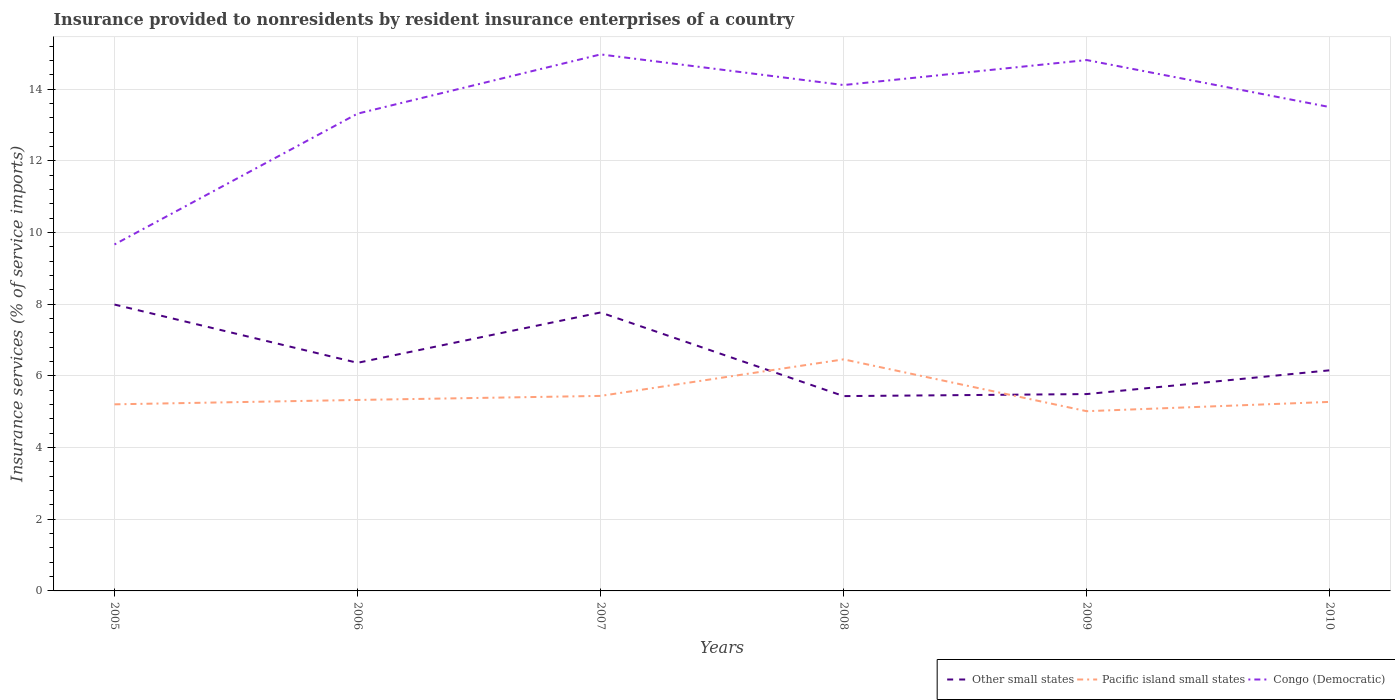How many different coloured lines are there?
Offer a terse response. 3. Does the line corresponding to Pacific island small states intersect with the line corresponding to Other small states?
Your answer should be very brief. Yes. Across all years, what is the maximum insurance provided to nonresidents in Other small states?
Your response must be concise. 5.43. What is the total insurance provided to nonresidents in Other small states in the graph?
Your answer should be compact. 1.63. What is the difference between the highest and the second highest insurance provided to nonresidents in Other small states?
Your answer should be compact. 2.55. What is the difference between the highest and the lowest insurance provided to nonresidents in Other small states?
Ensure brevity in your answer.  2. How many lines are there?
Offer a very short reply. 3. How many years are there in the graph?
Your answer should be very brief. 6. Are the values on the major ticks of Y-axis written in scientific E-notation?
Offer a very short reply. No. Does the graph contain grids?
Offer a very short reply. Yes. Where does the legend appear in the graph?
Keep it short and to the point. Bottom right. How are the legend labels stacked?
Provide a short and direct response. Horizontal. What is the title of the graph?
Keep it short and to the point. Insurance provided to nonresidents by resident insurance enterprises of a country. Does "Upper middle income" appear as one of the legend labels in the graph?
Keep it short and to the point. No. What is the label or title of the X-axis?
Make the answer very short. Years. What is the label or title of the Y-axis?
Provide a short and direct response. Insurance services (% of service imports). What is the Insurance services (% of service imports) of Other small states in 2005?
Provide a succinct answer. 7.99. What is the Insurance services (% of service imports) of Pacific island small states in 2005?
Provide a short and direct response. 5.21. What is the Insurance services (% of service imports) of Congo (Democratic) in 2005?
Provide a short and direct response. 9.66. What is the Insurance services (% of service imports) in Other small states in 2006?
Ensure brevity in your answer.  6.36. What is the Insurance services (% of service imports) in Pacific island small states in 2006?
Your answer should be compact. 5.33. What is the Insurance services (% of service imports) of Congo (Democratic) in 2006?
Give a very brief answer. 13.31. What is the Insurance services (% of service imports) in Other small states in 2007?
Provide a succinct answer. 7.77. What is the Insurance services (% of service imports) in Pacific island small states in 2007?
Keep it short and to the point. 5.44. What is the Insurance services (% of service imports) of Congo (Democratic) in 2007?
Give a very brief answer. 14.97. What is the Insurance services (% of service imports) of Other small states in 2008?
Your answer should be compact. 5.43. What is the Insurance services (% of service imports) in Pacific island small states in 2008?
Your answer should be compact. 6.46. What is the Insurance services (% of service imports) of Congo (Democratic) in 2008?
Your answer should be very brief. 14.11. What is the Insurance services (% of service imports) in Other small states in 2009?
Make the answer very short. 5.49. What is the Insurance services (% of service imports) in Pacific island small states in 2009?
Ensure brevity in your answer.  5.01. What is the Insurance services (% of service imports) in Congo (Democratic) in 2009?
Provide a short and direct response. 14.81. What is the Insurance services (% of service imports) in Other small states in 2010?
Ensure brevity in your answer.  6.15. What is the Insurance services (% of service imports) in Pacific island small states in 2010?
Offer a terse response. 5.27. What is the Insurance services (% of service imports) of Congo (Democratic) in 2010?
Make the answer very short. 13.5. Across all years, what is the maximum Insurance services (% of service imports) in Other small states?
Ensure brevity in your answer.  7.99. Across all years, what is the maximum Insurance services (% of service imports) of Pacific island small states?
Your answer should be very brief. 6.46. Across all years, what is the maximum Insurance services (% of service imports) of Congo (Democratic)?
Your response must be concise. 14.97. Across all years, what is the minimum Insurance services (% of service imports) in Other small states?
Make the answer very short. 5.43. Across all years, what is the minimum Insurance services (% of service imports) of Pacific island small states?
Provide a short and direct response. 5.01. Across all years, what is the minimum Insurance services (% of service imports) of Congo (Democratic)?
Make the answer very short. 9.66. What is the total Insurance services (% of service imports) in Other small states in the graph?
Provide a succinct answer. 39.2. What is the total Insurance services (% of service imports) of Pacific island small states in the graph?
Give a very brief answer. 32.72. What is the total Insurance services (% of service imports) of Congo (Democratic) in the graph?
Your answer should be very brief. 80.36. What is the difference between the Insurance services (% of service imports) in Other small states in 2005 and that in 2006?
Your response must be concise. 1.63. What is the difference between the Insurance services (% of service imports) of Pacific island small states in 2005 and that in 2006?
Keep it short and to the point. -0.12. What is the difference between the Insurance services (% of service imports) in Congo (Democratic) in 2005 and that in 2006?
Offer a terse response. -3.65. What is the difference between the Insurance services (% of service imports) in Other small states in 2005 and that in 2007?
Offer a terse response. 0.22. What is the difference between the Insurance services (% of service imports) of Pacific island small states in 2005 and that in 2007?
Ensure brevity in your answer.  -0.23. What is the difference between the Insurance services (% of service imports) of Congo (Democratic) in 2005 and that in 2007?
Provide a short and direct response. -5.3. What is the difference between the Insurance services (% of service imports) in Other small states in 2005 and that in 2008?
Keep it short and to the point. 2.55. What is the difference between the Insurance services (% of service imports) of Pacific island small states in 2005 and that in 2008?
Make the answer very short. -1.25. What is the difference between the Insurance services (% of service imports) of Congo (Democratic) in 2005 and that in 2008?
Your response must be concise. -4.45. What is the difference between the Insurance services (% of service imports) in Other small states in 2005 and that in 2009?
Provide a short and direct response. 2.5. What is the difference between the Insurance services (% of service imports) in Pacific island small states in 2005 and that in 2009?
Make the answer very short. 0.19. What is the difference between the Insurance services (% of service imports) of Congo (Democratic) in 2005 and that in 2009?
Your response must be concise. -5.14. What is the difference between the Insurance services (% of service imports) in Other small states in 2005 and that in 2010?
Provide a short and direct response. 1.83. What is the difference between the Insurance services (% of service imports) in Pacific island small states in 2005 and that in 2010?
Your answer should be very brief. -0.07. What is the difference between the Insurance services (% of service imports) in Congo (Democratic) in 2005 and that in 2010?
Your answer should be very brief. -3.83. What is the difference between the Insurance services (% of service imports) of Other small states in 2006 and that in 2007?
Your answer should be very brief. -1.4. What is the difference between the Insurance services (% of service imports) in Pacific island small states in 2006 and that in 2007?
Give a very brief answer. -0.11. What is the difference between the Insurance services (% of service imports) of Congo (Democratic) in 2006 and that in 2007?
Offer a very short reply. -1.65. What is the difference between the Insurance services (% of service imports) in Other small states in 2006 and that in 2008?
Your answer should be compact. 0.93. What is the difference between the Insurance services (% of service imports) in Pacific island small states in 2006 and that in 2008?
Ensure brevity in your answer.  -1.13. What is the difference between the Insurance services (% of service imports) of Congo (Democratic) in 2006 and that in 2008?
Offer a very short reply. -0.8. What is the difference between the Insurance services (% of service imports) of Other small states in 2006 and that in 2009?
Give a very brief answer. 0.87. What is the difference between the Insurance services (% of service imports) in Pacific island small states in 2006 and that in 2009?
Offer a very short reply. 0.31. What is the difference between the Insurance services (% of service imports) in Congo (Democratic) in 2006 and that in 2009?
Your answer should be very brief. -1.5. What is the difference between the Insurance services (% of service imports) of Other small states in 2006 and that in 2010?
Make the answer very short. 0.21. What is the difference between the Insurance services (% of service imports) in Pacific island small states in 2006 and that in 2010?
Your response must be concise. 0.05. What is the difference between the Insurance services (% of service imports) in Congo (Democratic) in 2006 and that in 2010?
Ensure brevity in your answer.  -0.18. What is the difference between the Insurance services (% of service imports) in Other small states in 2007 and that in 2008?
Give a very brief answer. 2.33. What is the difference between the Insurance services (% of service imports) in Pacific island small states in 2007 and that in 2008?
Make the answer very short. -1.02. What is the difference between the Insurance services (% of service imports) of Congo (Democratic) in 2007 and that in 2008?
Give a very brief answer. 0.85. What is the difference between the Insurance services (% of service imports) of Other small states in 2007 and that in 2009?
Your answer should be compact. 2.28. What is the difference between the Insurance services (% of service imports) in Pacific island small states in 2007 and that in 2009?
Give a very brief answer. 0.43. What is the difference between the Insurance services (% of service imports) in Congo (Democratic) in 2007 and that in 2009?
Provide a short and direct response. 0.16. What is the difference between the Insurance services (% of service imports) in Other small states in 2007 and that in 2010?
Offer a very short reply. 1.61. What is the difference between the Insurance services (% of service imports) in Pacific island small states in 2007 and that in 2010?
Keep it short and to the point. 0.17. What is the difference between the Insurance services (% of service imports) of Congo (Democratic) in 2007 and that in 2010?
Keep it short and to the point. 1.47. What is the difference between the Insurance services (% of service imports) in Other small states in 2008 and that in 2009?
Your answer should be very brief. -0.06. What is the difference between the Insurance services (% of service imports) in Pacific island small states in 2008 and that in 2009?
Give a very brief answer. 1.45. What is the difference between the Insurance services (% of service imports) of Congo (Democratic) in 2008 and that in 2009?
Give a very brief answer. -0.7. What is the difference between the Insurance services (% of service imports) in Other small states in 2008 and that in 2010?
Give a very brief answer. -0.72. What is the difference between the Insurance services (% of service imports) in Pacific island small states in 2008 and that in 2010?
Your response must be concise. 1.19. What is the difference between the Insurance services (% of service imports) in Congo (Democratic) in 2008 and that in 2010?
Your response must be concise. 0.61. What is the difference between the Insurance services (% of service imports) of Other small states in 2009 and that in 2010?
Your answer should be compact. -0.66. What is the difference between the Insurance services (% of service imports) of Pacific island small states in 2009 and that in 2010?
Make the answer very short. -0.26. What is the difference between the Insurance services (% of service imports) of Congo (Democratic) in 2009 and that in 2010?
Provide a succinct answer. 1.31. What is the difference between the Insurance services (% of service imports) of Other small states in 2005 and the Insurance services (% of service imports) of Pacific island small states in 2006?
Offer a terse response. 2.66. What is the difference between the Insurance services (% of service imports) of Other small states in 2005 and the Insurance services (% of service imports) of Congo (Democratic) in 2006?
Provide a short and direct response. -5.33. What is the difference between the Insurance services (% of service imports) in Pacific island small states in 2005 and the Insurance services (% of service imports) in Congo (Democratic) in 2006?
Provide a short and direct response. -8.11. What is the difference between the Insurance services (% of service imports) of Other small states in 2005 and the Insurance services (% of service imports) of Pacific island small states in 2007?
Offer a terse response. 2.55. What is the difference between the Insurance services (% of service imports) of Other small states in 2005 and the Insurance services (% of service imports) of Congo (Democratic) in 2007?
Ensure brevity in your answer.  -6.98. What is the difference between the Insurance services (% of service imports) of Pacific island small states in 2005 and the Insurance services (% of service imports) of Congo (Democratic) in 2007?
Offer a terse response. -9.76. What is the difference between the Insurance services (% of service imports) in Other small states in 2005 and the Insurance services (% of service imports) in Pacific island small states in 2008?
Give a very brief answer. 1.53. What is the difference between the Insurance services (% of service imports) of Other small states in 2005 and the Insurance services (% of service imports) of Congo (Democratic) in 2008?
Provide a short and direct response. -6.12. What is the difference between the Insurance services (% of service imports) of Pacific island small states in 2005 and the Insurance services (% of service imports) of Congo (Democratic) in 2008?
Make the answer very short. -8.91. What is the difference between the Insurance services (% of service imports) of Other small states in 2005 and the Insurance services (% of service imports) of Pacific island small states in 2009?
Offer a terse response. 2.98. What is the difference between the Insurance services (% of service imports) of Other small states in 2005 and the Insurance services (% of service imports) of Congo (Democratic) in 2009?
Your answer should be very brief. -6.82. What is the difference between the Insurance services (% of service imports) in Pacific island small states in 2005 and the Insurance services (% of service imports) in Congo (Democratic) in 2009?
Offer a very short reply. -9.6. What is the difference between the Insurance services (% of service imports) of Other small states in 2005 and the Insurance services (% of service imports) of Pacific island small states in 2010?
Provide a succinct answer. 2.72. What is the difference between the Insurance services (% of service imports) in Other small states in 2005 and the Insurance services (% of service imports) in Congo (Democratic) in 2010?
Make the answer very short. -5.51. What is the difference between the Insurance services (% of service imports) of Pacific island small states in 2005 and the Insurance services (% of service imports) of Congo (Democratic) in 2010?
Provide a short and direct response. -8.29. What is the difference between the Insurance services (% of service imports) of Other small states in 2006 and the Insurance services (% of service imports) of Pacific island small states in 2007?
Give a very brief answer. 0.92. What is the difference between the Insurance services (% of service imports) of Other small states in 2006 and the Insurance services (% of service imports) of Congo (Democratic) in 2007?
Provide a short and direct response. -8.6. What is the difference between the Insurance services (% of service imports) of Pacific island small states in 2006 and the Insurance services (% of service imports) of Congo (Democratic) in 2007?
Ensure brevity in your answer.  -9.64. What is the difference between the Insurance services (% of service imports) in Other small states in 2006 and the Insurance services (% of service imports) in Pacific island small states in 2008?
Your answer should be very brief. -0.1. What is the difference between the Insurance services (% of service imports) of Other small states in 2006 and the Insurance services (% of service imports) of Congo (Democratic) in 2008?
Offer a terse response. -7.75. What is the difference between the Insurance services (% of service imports) of Pacific island small states in 2006 and the Insurance services (% of service imports) of Congo (Democratic) in 2008?
Ensure brevity in your answer.  -8.78. What is the difference between the Insurance services (% of service imports) in Other small states in 2006 and the Insurance services (% of service imports) in Pacific island small states in 2009?
Provide a succinct answer. 1.35. What is the difference between the Insurance services (% of service imports) in Other small states in 2006 and the Insurance services (% of service imports) in Congo (Democratic) in 2009?
Provide a succinct answer. -8.45. What is the difference between the Insurance services (% of service imports) of Pacific island small states in 2006 and the Insurance services (% of service imports) of Congo (Democratic) in 2009?
Give a very brief answer. -9.48. What is the difference between the Insurance services (% of service imports) of Other small states in 2006 and the Insurance services (% of service imports) of Pacific island small states in 2010?
Give a very brief answer. 1.09. What is the difference between the Insurance services (% of service imports) in Other small states in 2006 and the Insurance services (% of service imports) in Congo (Democratic) in 2010?
Your answer should be very brief. -7.13. What is the difference between the Insurance services (% of service imports) in Pacific island small states in 2006 and the Insurance services (% of service imports) in Congo (Democratic) in 2010?
Offer a very short reply. -8.17. What is the difference between the Insurance services (% of service imports) of Other small states in 2007 and the Insurance services (% of service imports) of Pacific island small states in 2008?
Give a very brief answer. 1.31. What is the difference between the Insurance services (% of service imports) of Other small states in 2007 and the Insurance services (% of service imports) of Congo (Democratic) in 2008?
Offer a terse response. -6.34. What is the difference between the Insurance services (% of service imports) in Pacific island small states in 2007 and the Insurance services (% of service imports) in Congo (Democratic) in 2008?
Ensure brevity in your answer.  -8.67. What is the difference between the Insurance services (% of service imports) in Other small states in 2007 and the Insurance services (% of service imports) in Pacific island small states in 2009?
Provide a short and direct response. 2.75. What is the difference between the Insurance services (% of service imports) of Other small states in 2007 and the Insurance services (% of service imports) of Congo (Democratic) in 2009?
Offer a terse response. -7.04. What is the difference between the Insurance services (% of service imports) in Pacific island small states in 2007 and the Insurance services (% of service imports) in Congo (Democratic) in 2009?
Offer a very short reply. -9.37. What is the difference between the Insurance services (% of service imports) of Other small states in 2007 and the Insurance services (% of service imports) of Pacific island small states in 2010?
Ensure brevity in your answer.  2.49. What is the difference between the Insurance services (% of service imports) in Other small states in 2007 and the Insurance services (% of service imports) in Congo (Democratic) in 2010?
Offer a terse response. -5.73. What is the difference between the Insurance services (% of service imports) of Pacific island small states in 2007 and the Insurance services (% of service imports) of Congo (Democratic) in 2010?
Provide a succinct answer. -8.06. What is the difference between the Insurance services (% of service imports) in Other small states in 2008 and the Insurance services (% of service imports) in Pacific island small states in 2009?
Offer a very short reply. 0.42. What is the difference between the Insurance services (% of service imports) in Other small states in 2008 and the Insurance services (% of service imports) in Congo (Democratic) in 2009?
Offer a terse response. -9.37. What is the difference between the Insurance services (% of service imports) of Pacific island small states in 2008 and the Insurance services (% of service imports) of Congo (Democratic) in 2009?
Make the answer very short. -8.35. What is the difference between the Insurance services (% of service imports) in Other small states in 2008 and the Insurance services (% of service imports) in Pacific island small states in 2010?
Offer a terse response. 0.16. What is the difference between the Insurance services (% of service imports) in Other small states in 2008 and the Insurance services (% of service imports) in Congo (Democratic) in 2010?
Provide a succinct answer. -8.06. What is the difference between the Insurance services (% of service imports) in Pacific island small states in 2008 and the Insurance services (% of service imports) in Congo (Democratic) in 2010?
Your answer should be compact. -7.04. What is the difference between the Insurance services (% of service imports) in Other small states in 2009 and the Insurance services (% of service imports) in Pacific island small states in 2010?
Give a very brief answer. 0.22. What is the difference between the Insurance services (% of service imports) of Other small states in 2009 and the Insurance services (% of service imports) of Congo (Democratic) in 2010?
Your answer should be very brief. -8.01. What is the difference between the Insurance services (% of service imports) of Pacific island small states in 2009 and the Insurance services (% of service imports) of Congo (Democratic) in 2010?
Your response must be concise. -8.48. What is the average Insurance services (% of service imports) in Other small states per year?
Your answer should be very brief. 6.53. What is the average Insurance services (% of service imports) in Pacific island small states per year?
Your answer should be very brief. 5.45. What is the average Insurance services (% of service imports) of Congo (Democratic) per year?
Your answer should be compact. 13.39. In the year 2005, what is the difference between the Insurance services (% of service imports) in Other small states and Insurance services (% of service imports) in Pacific island small states?
Your response must be concise. 2.78. In the year 2005, what is the difference between the Insurance services (% of service imports) of Other small states and Insurance services (% of service imports) of Congo (Democratic)?
Your response must be concise. -1.68. In the year 2005, what is the difference between the Insurance services (% of service imports) in Pacific island small states and Insurance services (% of service imports) in Congo (Democratic)?
Keep it short and to the point. -4.46. In the year 2006, what is the difference between the Insurance services (% of service imports) in Other small states and Insurance services (% of service imports) in Pacific island small states?
Ensure brevity in your answer.  1.04. In the year 2006, what is the difference between the Insurance services (% of service imports) of Other small states and Insurance services (% of service imports) of Congo (Democratic)?
Offer a terse response. -6.95. In the year 2006, what is the difference between the Insurance services (% of service imports) of Pacific island small states and Insurance services (% of service imports) of Congo (Democratic)?
Ensure brevity in your answer.  -7.99. In the year 2007, what is the difference between the Insurance services (% of service imports) in Other small states and Insurance services (% of service imports) in Pacific island small states?
Provide a short and direct response. 2.33. In the year 2007, what is the difference between the Insurance services (% of service imports) in Other small states and Insurance services (% of service imports) in Congo (Democratic)?
Ensure brevity in your answer.  -7.2. In the year 2007, what is the difference between the Insurance services (% of service imports) in Pacific island small states and Insurance services (% of service imports) in Congo (Democratic)?
Make the answer very short. -9.53. In the year 2008, what is the difference between the Insurance services (% of service imports) in Other small states and Insurance services (% of service imports) in Pacific island small states?
Give a very brief answer. -1.02. In the year 2008, what is the difference between the Insurance services (% of service imports) in Other small states and Insurance services (% of service imports) in Congo (Democratic)?
Keep it short and to the point. -8.68. In the year 2008, what is the difference between the Insurance services (% of service imports) in Pacific island small states and Insurance services (% of service imports) in Congo (Democratic)?
Offer a very short reply. -7.65. In the year 2009, what is the difference between the Insurance services (% of service imports) in Other small states and Insurance services (% of service imports) in Pacific island small states?
Ensure brevity in your answer.  0.48. In the year 2009, what is the difference between the Insurance services (% of service imports) in Other small states and Insurance services (% of service imports) in Congo (Democratic)?
Keep it short and to the point. -9.32. In the year 2009, what is the difference between the Insurance services (% of service imports) of Pacific island small states and Insurance services (% of service imports) of Congo (Democratic)?
Provide a short and direct response. -9.8. In the year 2010, what is the difference between the Insurance services (% of service imports) in Other small states and Insurance services (% of service imports) in Pacific island small states?
Your response must be concise. 0.88. In the year 2010, what is the difference between the Insurance services (% of service imports) in Other small states and Insurance services (% of service imports) in Congo (Democratic)?
Provide a short and direct response. -7.34. In the year 2010, what is the difference between the Insurance services (% of service imports) of Pacific island small states and Insurance services (% of service imports) of Congo (Democratic)?
Offer a very short reply. -8.22. What is the ratio of the Insurance services (% of service imports) in Other small states in 2005 to that in 2006?
Offer a very short reply. 1.26. What is the ratio of the Insurance services (% of service imports) in Pacific island small states in 2005 to that in 2006?
Your response must be concise. 0.98. What is the ratio of the Insurance services (% of service imports) of Congo (Democratic) in 2005 to that in 2006?
Make the answer very short. 0.73. What is the ratio of the Insurance services (% of service imports) in Other small states in 2005 to that in 2007?
Give a very brief answer. 1.03. What is the ratio of the Insurance services (% of service imports) of Pacific island small states in 2005 to that in 2007?
Your answer should be very brief. 0.96. What is the ratio of the Insurance services (% of service imports) of Congo (Democratic) in 2005 to that in 2007?
Give a very brief answer. 0.65. What is the ratio of the Insurance services (% of service imports) of Other small states in 2005 to that in 2008?
Ensure brevity in your answer.  1.47. What is the ratio of the Insurance services (% of service imports) in Pacific island small states in 2005 to that in 2008?
Make the answer very short. 0.81. What is the ratio of the Insurance services (% of service imports) of Congo (Democratic) in 2005 to that in 2008?
Your response must be concise. 0.68. What is the ratio of the Insurance services (% of service imports) in Other small states in 2005 to that in 2009?
Give a very brief answer. 1.45. What is the ratio of the Insurance services (% of service imports) of Pacific island small states in 2005 to that in 2009?
Your answer should be very brief. 1.04. What is the ratio of the Insurance services (% of service imports) of Congo (Democratic) in 2005 to that in 2009?
Make the answer very short. 0.65. What is the ratio of the Insurance services (% of service imports) of Other small states in 2005 to that in 2010?
Your answer should be compact. 1.3. What is the ratio of the Insurance services (% of service imports) of Pacific island small states in 2005 to that in 2010?
Your answer should be compact. 0.99. What is the ratio of the Insurance services (% of service imports) of Congo (Democratic) in 2005 to that in 2010?
Ensure brevity in your answer.  0.72. What is the ratio of the Insurance services (% of service imports) of Other small states in 2006 to that in 2007?
Your answer should be compact. 0.82. What is the ratio of the Insurance services (% of service imports) in Pacific island small states in 2006 to that in 2007?
Ensure brevity in your answer.  0.98. What is the ratio of the Insurance services (% of service imports) of Congo (Democratic) in 2006 to that in 2007?
Offer a very short reply. 0.89. What is the ratio of the Insurance services (% of service imports) of Other small states in 2006 to that in 2008?
Provide a succinct answer. 1.17. What is the ratio of the Insurance services (% of service imports) in Pacific island small states in 2006 to that in 2008?
Your response must be concise. 0.82. What is the ratio of the Insurance services (% of service imports) in Congo (Democratic) in 2006 to that in 2008?
Offer a very short reply. 0.94. What is the ratio of the Insurance services (% of service imports) in Other small states in 2006 to that in 2009?
Your answer should be compact. 1.16. What is the ratio of the Insurance services (% of service imports) of Congo (Democratic) in 2006 to that in 2009?
Your answer should be compact. 0.9. What is the ratio of the Insurance services (% of service imports) of Other small states in 2006 to that in 2010?
Keep it short and to the point. 1.03. What is the ratio of the Insurance services (% of service imports) in Pacific island small states in 2006 to that in 2010?
Ensure brevity in your answer.  1.01. What is the ratio of the Insurance services (% of service imports) of Congo (Democratic) in 2006 to that in 2010?
Offer a terse response. 0.99. What is the ratio of the Insurance services (% of service imports) in Other small states in 2007 to that in 2008?
Ensure brevity in your answer.  1.43. What is the ratio of the Insurance services (% of service imports) of Pacific island small states in 2007 to that in 2008?
Ensure brevity in your answer.  0.84. What is the ratio of the Insurance services (% of service imports) in Congo (Democratic) in 2007 to that in 2008?
Make the answer very short. 1.06. What is the ratio of the Insurance services (% of service imports) in Other small states in 2007 to that in 2009?
Make the answer very short. 1.41. What is the ratio of the Insurance services (% of service imports) in Pacific island small states in 2007 to that in 2009?
Your answer should be very brief. 1.09. What is the ratio of the Insurance services (% of service imports) in Congo (Democratic) in 2007 to that in 2009?
Make the answer very short. 1.01. What is the ratio of the Insurance services (% of service imports) in Other small states in 2007 to that in 2010?
Offer a very short reply. 1.26. What is the ratio of the Insurance services (% of service imports) in Pacific island small states in 2007 to that in 2010?
Your answer should be very brief. 1.03. What is the ratio of the Insurance services (% of service imports) in Congo (Democratic) in 2007 to that in 2010?
Your answer should be compact. 1.11. What is the ratio of the Insurance services (% of service imports) of Pacific island small states in 2008 to that in 2009?
Provide a short and direct response. 1.29. What is the ratio of the Insurance services (% of service imports) in Congo (Democratic) in 2008 to that in 2009?
Ensure brevity in your answer.  0.95. What is the ratio of the Insurance services (% of service imports) in Other small states in 2008 to that in 2010?
Make the answer very short. 0.88. What is the ratio of the Insurance services (% of service imports) in Pacific island small states in 2008 to that in 2010?
Provide a short and direct response. 1.23. What is the ratio of the Insurance services (% of service imports) of Congo (Democratic) in 2008 to that in 2010?
Make the answer very short. 1.05. What is the ratio of the Insurance services (% of service imports) in Other small states in 2009 to that in 2010?
Offer a terse response. 0.89. What is the ratio of the Insurance services (% of service imports) in Pacific island small states in 2009 to that in 2010?
Make the answer very short. 0.95. What is the ratio of the Insurance services (% of service imports) in Congo (Democratic) in 2009 to that in 2010?
Your response must be concise. 1.1. What is the difference between the highest and the second highest Insurance services (% of service imports) in Other small states?
Your response must be concise. 0.22. What is the difference between the highest and the second highest Insurance services (% of service imports) of Pacific island small states?
Give a very brief answer. 1.02. What is the difference between the highest and the second highest Insurance services (% of service imports) in Congo (Democratic)?
Provide a succinct answer. 0.16. What is the difference between the highest and the lowest Insurance services (% of service imports) in Other small states?
Your response must be concise. 2.55. What is the difference between the highest and the lowest Insurance services (% of service imports) in Pacific island small states?
Your response must be concise. 1.45. What is the difference between the highest and the lowest Insurance services (% of service imports) of Congo (Democratic)?
Offer a terse response. 5.3. 